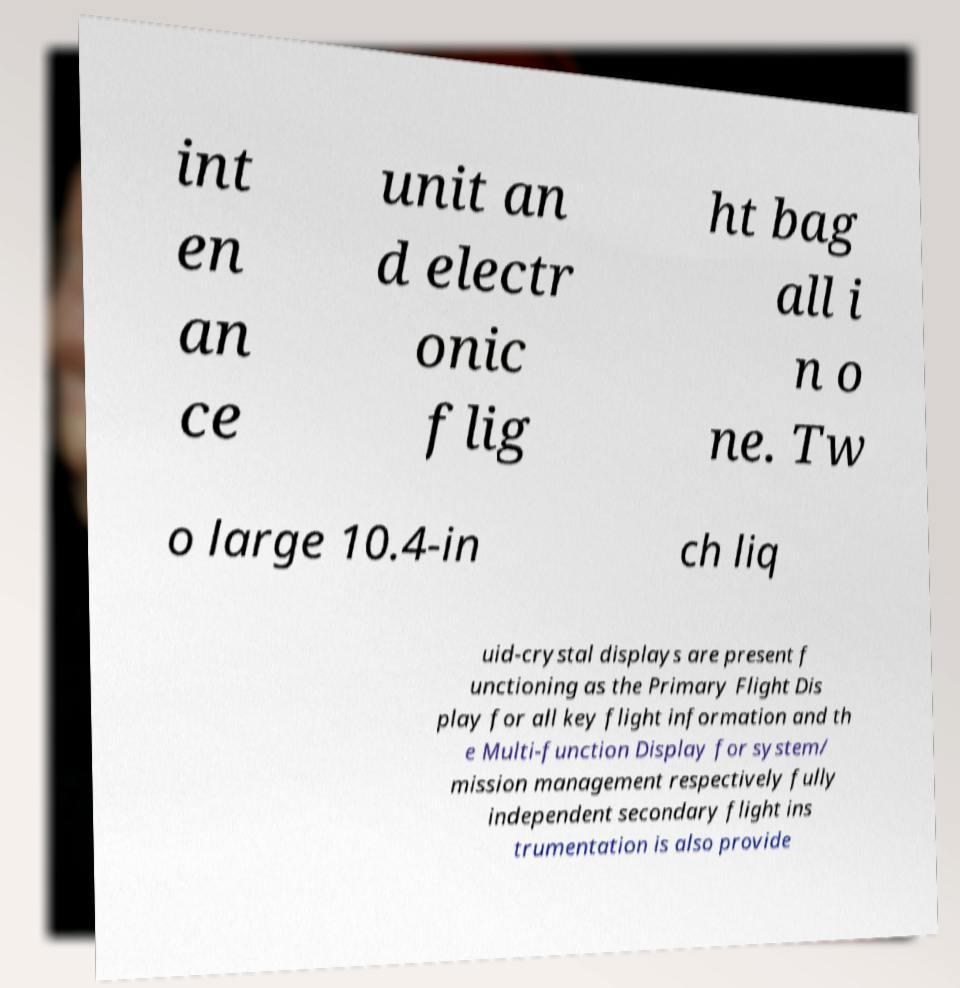For documentation purposes, I need the text within this image transcribed. Could you provide that? int en an ce unit an d electr onic flig ht bag all i n o ne. Tw o large 10.4-in ch liq uid-crystal displays are present f unctioning as the Primary Flight Dis play for all key flight information and th e Multi-function Display for system/ mission management respectively fully independent secondary flight ins trumentation is also provide 